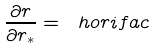Convert formula to latex. <formula><loc_0><loc_0><loc_500><loc_500>\frac { \partial r } { \partial r _ { * } } = \ h o r i f a c</formula> 